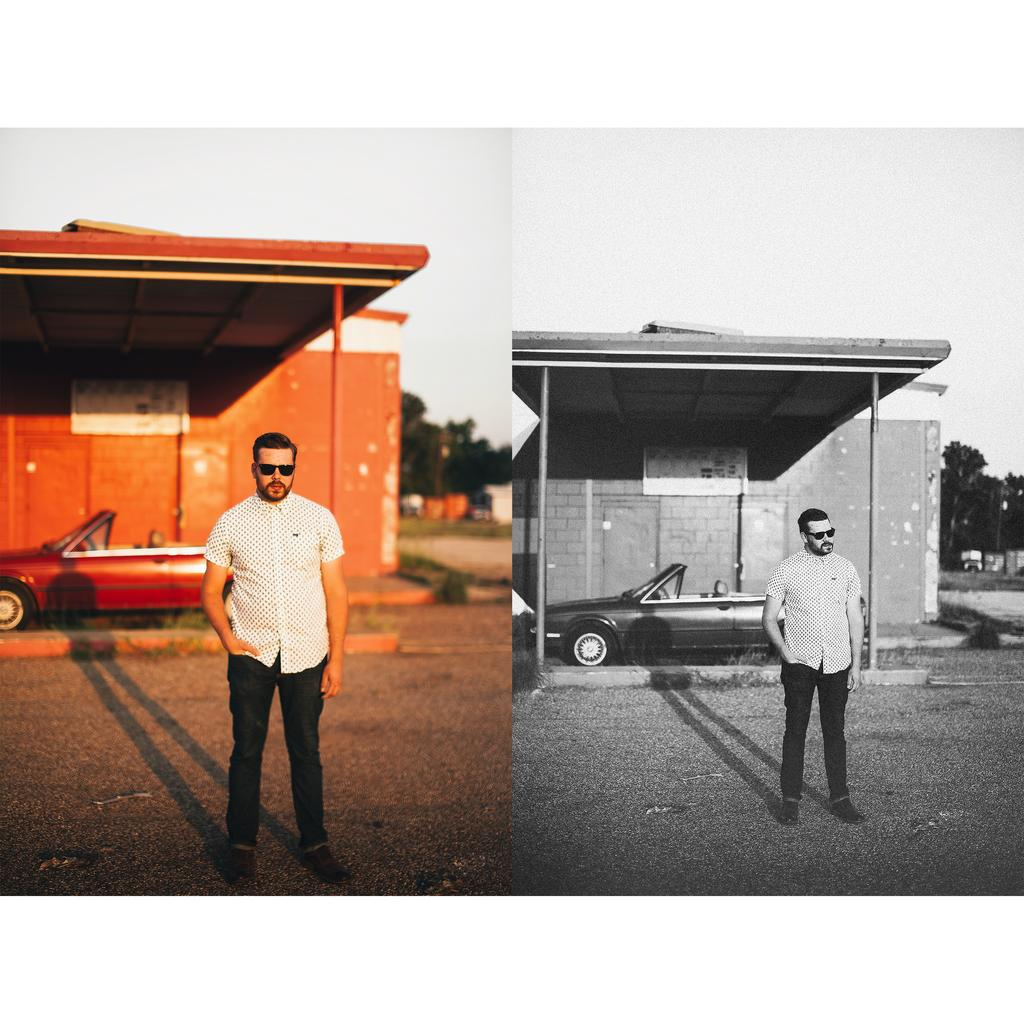How many people are present in the image? There are two people in the image. What else can be seen in the image besides the people? Cars, houses, boards, trees, and the sky are visible in the image. What is the color of the sky in the image? The sky is white in color. What type of force is being applied to the trees in the image? There is no force being applied to the trees in the image; they are stationary. Can you describe the activity involving a whip in the image? There is no activity involving a whip in the image. 